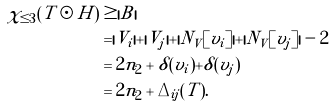Convert formula to latex. <formula><loc_0><loc_0><loc_500><loc_500>\chi _ { \leq 3 } ( T \odot H ) & \geq | B | \\ & = | V _ { i } | + | V _ { j } | + | N _ { V } [ v _ { i } ] | + | N _ { V } [ v _ { j } ] | - 2 \\ & = 2 n _ { 2 } + \delta ( v _ { i } ) + \delta ( v _ { j } ) \\ & = 2 n _ { 2 } + \Delta _ { i j } ( T ) .</formula> 